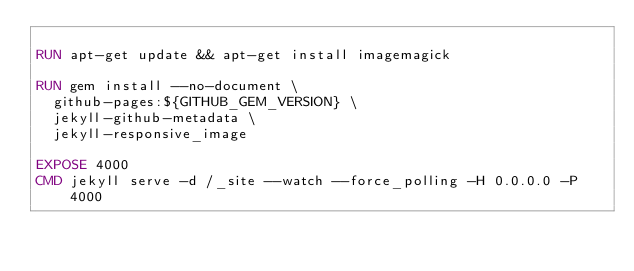<code> <loc_0><loc_0><loc_500><loc_500><_Dockerfile_>
RUN apt-get update && apt-get install imagemagick

RUN gem install --no-document \
  github-pages:${GITHUB_GEM_VERSION} \
  jekyll-github-metadata \
  jekyll-responsive_image

EXPOSE 4000
CMD jekyll serve -d /_site --watch --force_polling -H 0.0.0.0 -P 4000</code> 